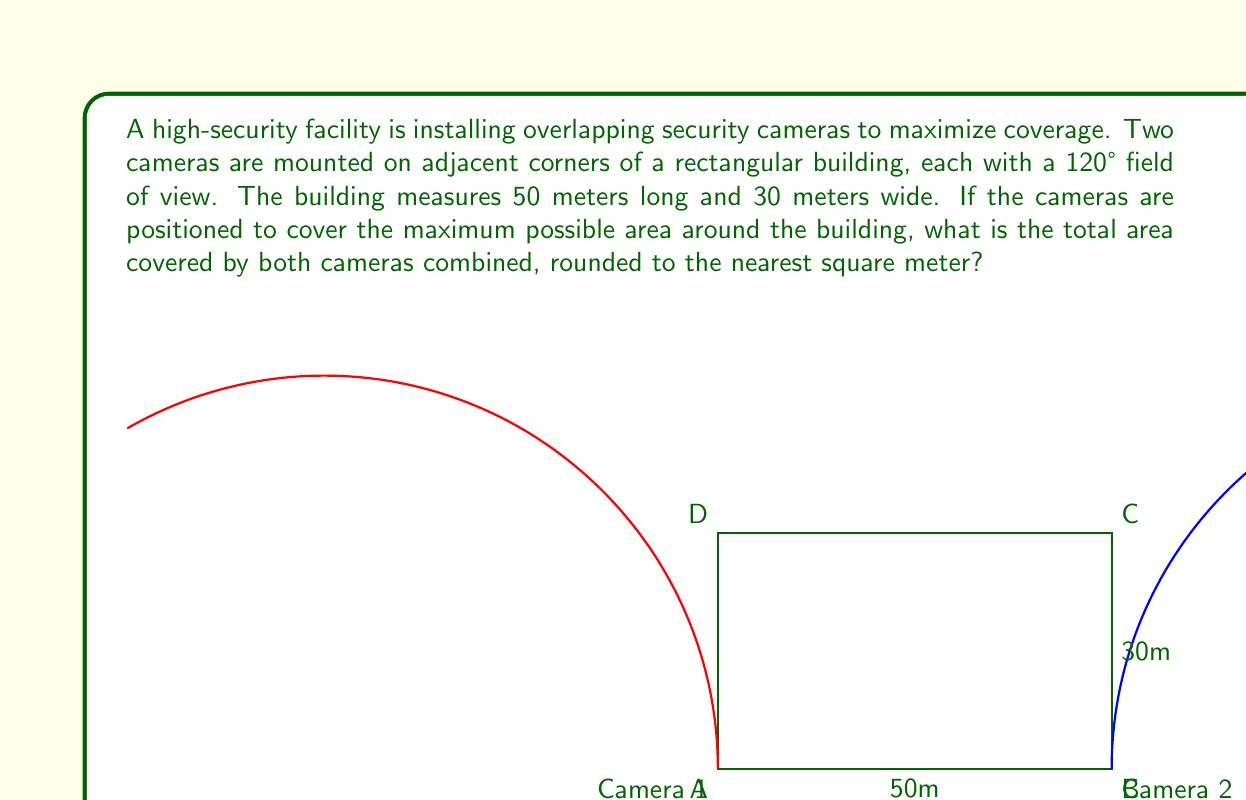What is the answer to this math problem? To solve this problem, we'll follow these steps:

1) First, we need to calculate the area covered by each camera individually.

2) The area covered by each camera is a sector of a circle. The area of a sector is given by the formula:

   $$A = \frac{1}{2}r^2\theta$$

   where $r$ is the radius and $\theta$ is the angle in radians.

3) The angle is 120°, which we need to convert to radians:

   $$\theta = 120° \times \frac{\pi}{180°} = \frac{2\pi}{3} \text{ radians}$$

4) We don't know the radius yet, but we can find it using the Pythagorean theorem:

   $$r^2 = 50^2 + 30^2 = 3400$$
   $$r = \sqrt{3400} \approx 58.31 \text{ meters}$$

5) Now we can calculate the area of each sector:

   $$A = \frac{1}{2} \times 58.31^2 \times \frac{2\pi}{3} \approx 3557.37 \text{ sq meters}$$

6) However, this includes the area of the building itself. We need to subtract the area of the building:

   $$A_{building} = 50 \times 30 = 1500 \text{ sq meters}$$

7) So the area covered by each camera outside the building is:

   $$3557.37 - 1500 = 2057.37 \text{ sq meters}$$

8) Since there are two cameras, we multiply this by 2:

   $$2 \times 2057.37 = 4114.74 \text{ sq meters}$$

9) However, this double-counts the overlapping area. The overlap is a rhombus-shaped area in front of the building. To calculate this, we need to find the intersection point of the two arcs.

10) The intersection point forms an equilateral triangle with the two camera positions. The height of this triangle is 30 meters (the width of the building). We can use this to find the side length:

    $$\text{side} = \frac{2 \times 30}{\sqrt{3}} \approx 34.64 \text{ meters}$$

11) The area of the rhombus is then:

    $$A_{overlap} = 34.64 \times 30 = 1039.2 \text{ sq meters}$$

12) Therefore, the total area covered is:

    $$4114.74 - 1039.2 = 3075.54 \text{ sq meters}$$

13) Rounding to the nearest square meter gives us 3076 sq meters.
Answer: 3076 square meters 